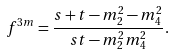<formula> <loc_0><loc_0><loc_500><loc_500>f ^ { 3 m } = \frac { s + t - m _ { 2 } ^ { 2 } - m _ { 4 } ^ { 2 } } { s t - m _ { 2 } ^ { 2 } m _ { 4 } ^ { 2 } } .</formula> 